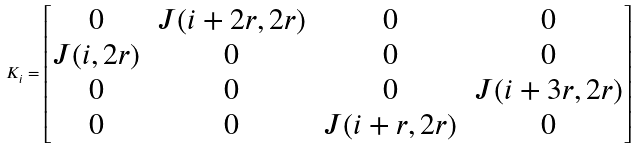Convert formula to latex. <formula><loc_0><loc_0><loc_500><loc_500>K _ { i } = \begin{bmatrix} 0 & J ( i + 2 r , 2 r ) & 0 & 0 \\ J ( i , 2 r ) & 0 & 0 & 0 \\ 0 & 0 & 0 & J ( i + 3 r , 2 r ) \\ 0 & 0 & J ( i + r , 2 r ) & 0 \\ \end{bmatrix}</formula> 